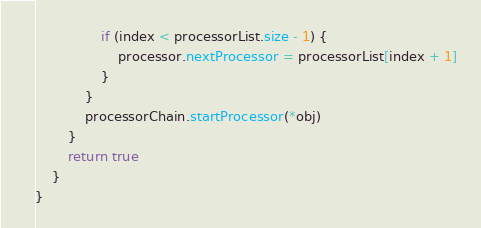<code> <loc_0><loc_0><loc_500><loc_500><_Kotlin_>                if (index < processorList.size - 1) {
                    processor.nextProcessor = processorList[index + 1]
                }
            }
            processorChain.startProcessor(*obj)
        }
        return true
    }
}</code> 